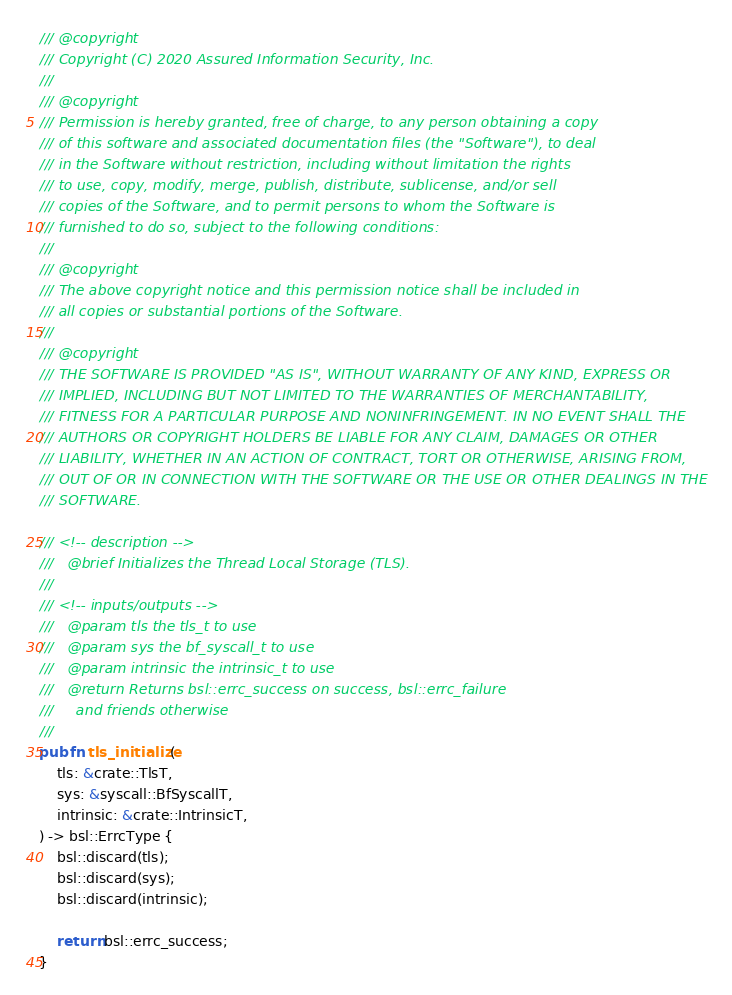<code> <loc_0><loc_0><loc_500><loc_500><_Rust_>/// @copyright
/// Copyright (C) 2020 Assured Information Security, Inc.
///
/// @copyright
/// Permission is hereby granted, free of charge, to any person obtaining a copy
/// of this software and associated documentation files (the "Software"), to deal
/// in the Software without restriction, including without limitation the rights
/// to use, copy, modify, merge, publish, distribute, sublicense, and/or sell
/// copies of the Software, and to permit persons to whom the Software is
/// furnished to do so, subject to the following conditions:
///
/// @copyright
/// The above copyright notice and this permission notice shall be included in
/// all copies or substantial portions of the Software.
///
/// @copyright
/// THE SOFTWARE IS PROVIDED "AS IS", WITHOUT WARRANTY OF ANY KIND, EXPRESS OR
/// IMPLIED, INCLUDING BUT NOT LIMITED TO THE WARRANTIES OF MERCHANTABILITY,
/// FITNESS FOR A PARTICULAR PURPOSE AND NONINFRINGEMENT. IN NO EVENT SHALL THE
/// AUTHORS OR COPYRIGHT HOLDERS BE LIABLE FOR ANY CLAIM, DAMAGES OR OTHER
/// LIABILITY, WHETHER IN AN ACTION OF CONTRACT, TORT OR OTHERWISE, ARISING FROM,
/// OUT OF OR IN CONNECTION WITH THE SOFTWARE OR THE USE OR OTHER DEALINGS IN THE
/// SOFTWARE.

/// <!-- description -->
///   @brief Initializes the Thread Local Storage (TLS).
///
/// <!-- inputs/outputs -->
///   @param tls the tls_t to use
///   @param sys the bf_syscall_t to use
///   @param intrinsic the intrinsic_t to use
///   @return Returns bsl::errc_success on success, bsl::errc_failure
///     and friends otherwise
///
pub fn tls_initialize(
    tls: &crate::TlsT,
    sys: &syscall::BfSyscallT,
    intrinsic: &crate::IntrinsicT,
) -> bsl::ErrcType {
    bsl::discard(tls);
    bsl::discard(sys);
    bsl::discard(intrinsic);

    return bsl::errc_success;
}
</code> 